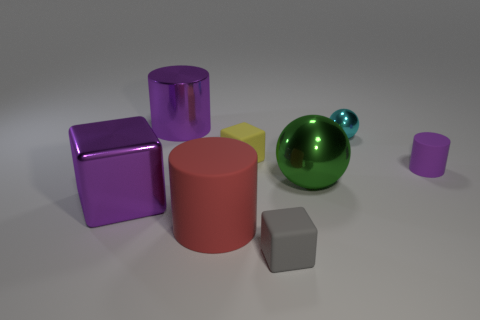Is the tiny cyan metallic object the same shape as the small purple rubber thing?
Your response must be concise. No. What material is the tiny cylinder that is the same color as the big metal cylinder?
Your answer should be very brief. Rubber. Does the tiny matte cylinder have the same color as the metallic cube?
Your answer should be compact. Yes. There is a big purple thing in front of the purple cylinder to the right of the small gray thing; what number of metallic things are on the left side of it?
Provide a succinct answer. 0. The tiny gray object that is the same material as the yellow block is what shape?
Your answer should be compact. Cube. There is a cylinder to the right of the gray rubber block that is right of the purple thing that is left of the large metal cylinder; what is it made of?
Provide a short and direct response. Rubber. What number of objects are small gray blocks that are in front of the red cylinder or cyan metallic objects?
Ensure brevity in your answer.  2. What number of other objects are there of the same shape as the green object?
Give a very brief answer. 1. Are there more tiny purple cylinders that are on the left side of the green ball than large gray balls?
Your answer should be very brief. No. What is the size of the other purple rubber object that is the same shape as the big rubber object?
Provide a short and direct response. Small. 